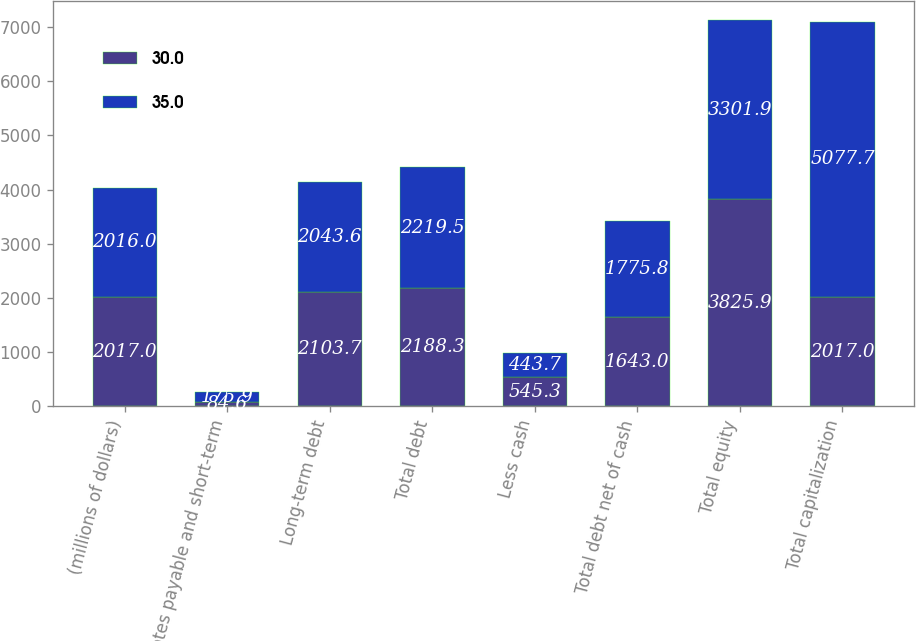<chart> <loc_0><loc_0><loc_500><loc_500><stacked_bar_chart><ecel><fcel>(millions of dollars)<fcel>Notes payable and short-term<fcel>Long-term debt<fcel>Total debt<fcel>Less cash<fcel>Total debt net of cash<fcel>Total equity<fcel>Total capitalization<nl><fcel>30<fcel>2017<fcel>84.6<fcel>2103.7<fcel>2188.3<fcel>545.3<fcel>1643<fcel>3825.9<fcel>2017<nl><fcel>35<fcel>2016<fcel>175.9<fcel>2043.6<fcel>2219.5<fcel>443.7<fcel>1775.8<fcel>3301.9<fcel>5077.7<nl></chart> 